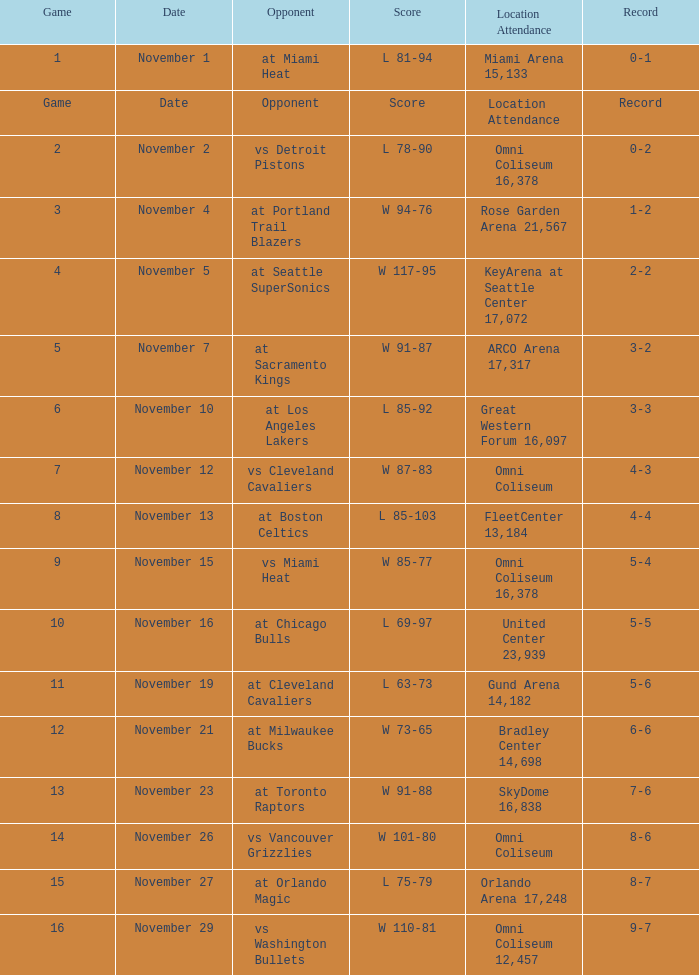On what date was game 3? November 4. Could you help me parse every detail presented in this table? {'header': ['Game', 'Date', 'Opponent', 'Score', 'Location Attendance', 'Record'], 'rows': [['1', 'November 1', 'at Miami Heat', 'L 81-94', 'Miami Arena 15,133', '0-1'], ['Game', 'Date', 'Opponent', 'Score', 'Location Attendance', 'Record'], ['2', 'November 2', 'vs Detroit Pistons', 'L 78-90', 'Omni Coliseum 16,378', '0-2'], ['3', 'November 4', 'at Portland Trail Blazers', 'W 94-76', 'Rose Garden Arena 21,567', '1-2'], ['4', 'November 5', 'at Seattle SuperSonics', 'W 117-95', 'KeyArena at Seattle Center 17,072', '2-2'], ['5', 'November 7', 'at Sacramento Kings', 'W 91-87', 'ARCO Arena 17,317', '3-2'], ['6', 'November 10', 'at Los Angeles Lakers', 'L 85-92', 'Great Western Forum 16,097', '3-3'], ['7', 'November 12', 'vs Cleveland Cavaliers', 'W 87-83', 'Omni Coliseum', '4-3'], ['8', 'November 13', 'at Boston Celtics', 'L 85-103', 'FleetCenter 13,184', '4-4'], ['9', 'November 15', 'vs Miami Heat', 'W 85-77', 'Omni Coliseum 16,378', '5-4'], ['10', 'November 16', 'at Chicago Bulls', 'L 69-97', 'United Center 23,939', '5-5'], ['11', 'November 19', 'at Cleveland Cavaliers', 'L 63-73', 'Gund Arena 14,182', '5-6'], ['12', 'November 21', 'at Milwaukee Bucks', 'W 73-65', 'Bradley Center 14,698', '6-6'], ['13', 'November 23', 'at Toronto Raptors', 'W 91-88', 'SkyDome 16,838', '7-6'], ['14', 'November 26', 'vs Vancouver Grizzlies', 'W 101-80', 'Omni Coliseum', '8-6'], ['15', 'November 27', 'at Orlando Magic', 'L 75-79', 'Orlando Arena 17,248', '8-7'], ['16', 'November 29', 'vs Washington Bullets', 'W 110-81', 'Omni Coliseum 12,457', '9-7']]} 